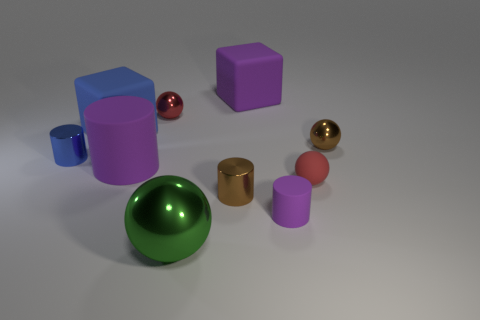What number of objects are small purple shiny spheres or metal balls behind the green metallic ball?
Ensure brevity in your answer.  2. There is a small cylinder to the left of the big purple rubber thing in front of the blue cube; how many purple cylinders are behind it?
Offer a terse response. 0. Do the large purple matte thing that is to the left of the large metallic thing and the red metallic thing have the same shape?
Provide a succinct answer. No. There is a tiny metallic sphere on the left side of the green metal object; are there any brown metallic balls on the left side of it?
Ensure brevity in your answer.  No. What number of small yellow metallic blocks are there?
Your response must be concise. 0. There is a big object that is on the right side of the big cylinder and in front of the blue metal thing; what color is it?
Provide a short and direct response. Green. There is a blue object that is the same shape as the tiny purple rubber thing; what size is it?
Offer a very short reply. Small. What number of red metallic cylinders have the same size as the green ball?
Your response must be concise. 0. What material is the big blue block?
Your answer should be compact. Rubber. Are there any big rubber things in front of the purple block?
Offer a very short reply. Yes. 